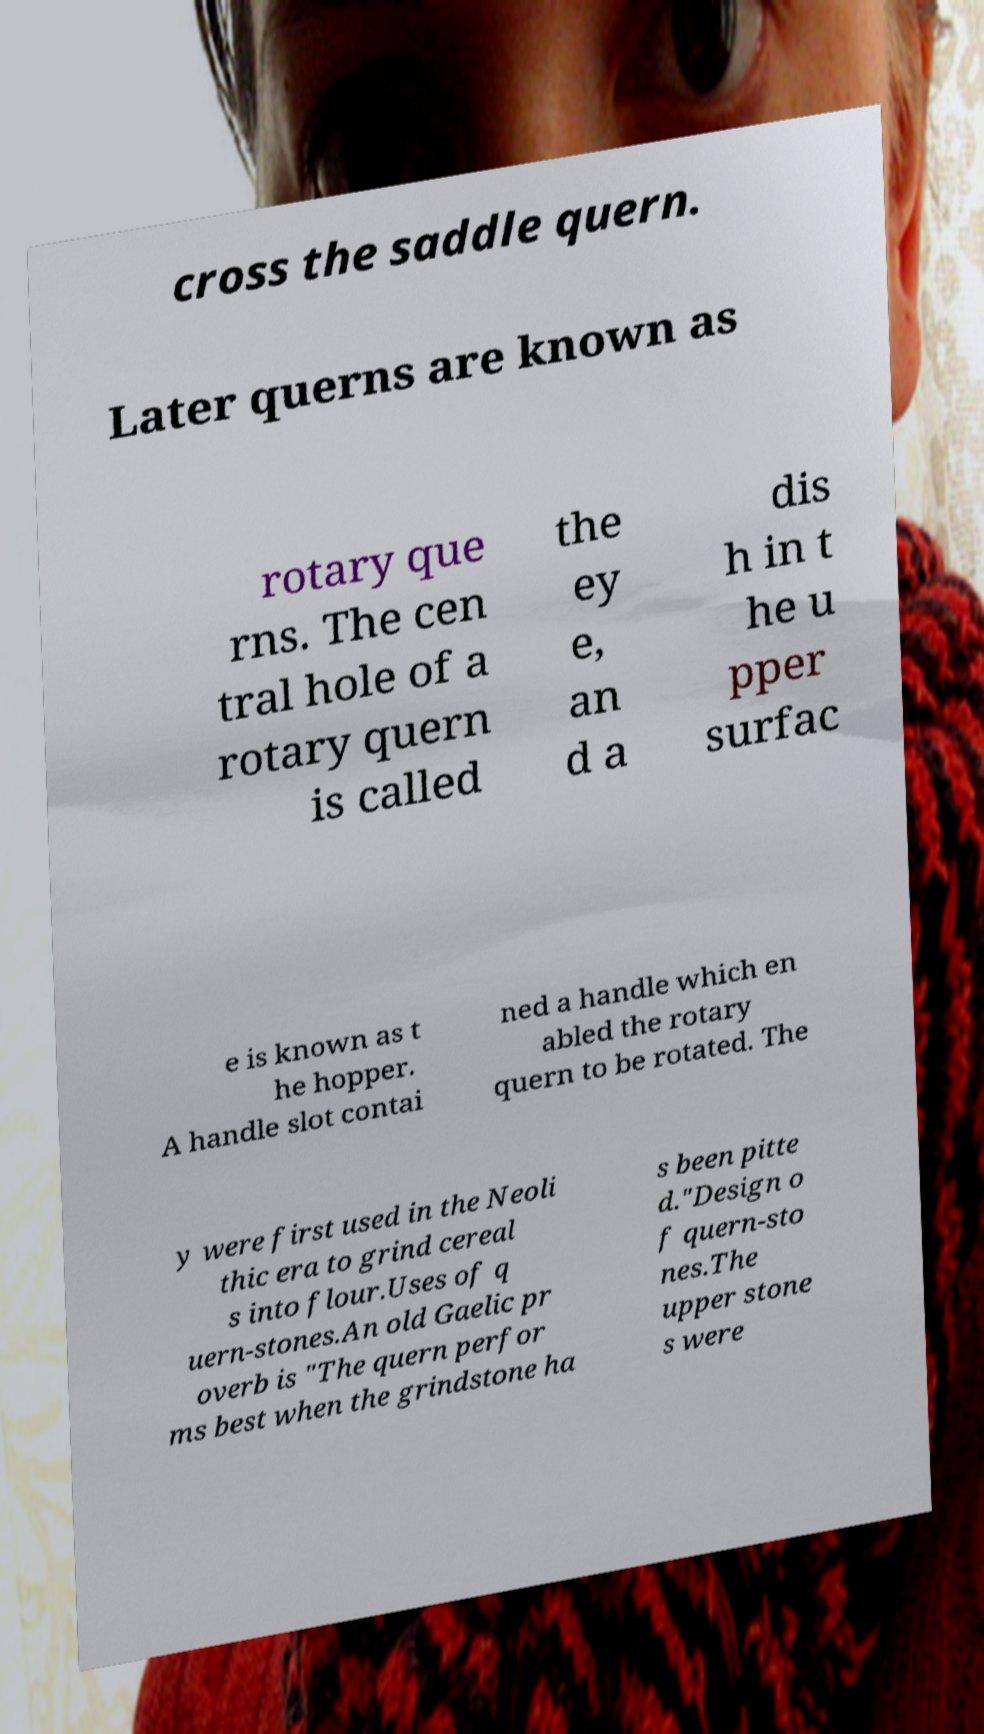I need the written content from this picture converted into text. Can you do that? cross the saddle quern. Later querns are known as rotary que rns. The cen tral hole of a rotary quern is called the ey e, an d a dis h in t he u pper surfac e is known as t he hopper. A handle slot contai ned a handle which en abled the rotary quern to be rotated. The y were first used in the Neoli thic era to grind cereal s into flour.Uses of q uern-stones.An old Gaelic pr overb is "The quern perfor ms best when the grindstone ha s been pitte d."Design o f quern-sto nes.The upper stone s were 